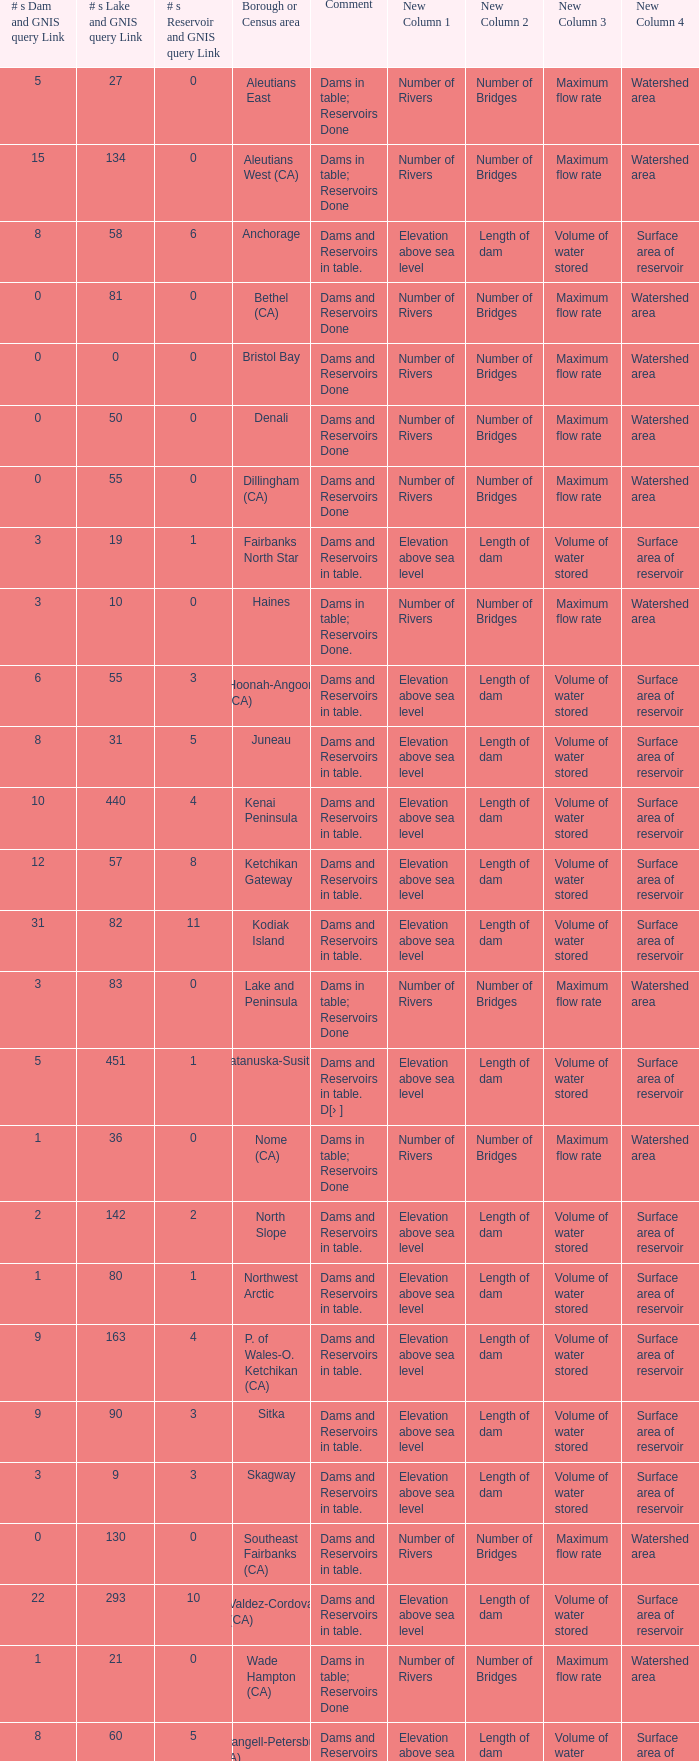Name the most numbers dam and gnis query link for borough or census area for fairbanks north star 3.0. 